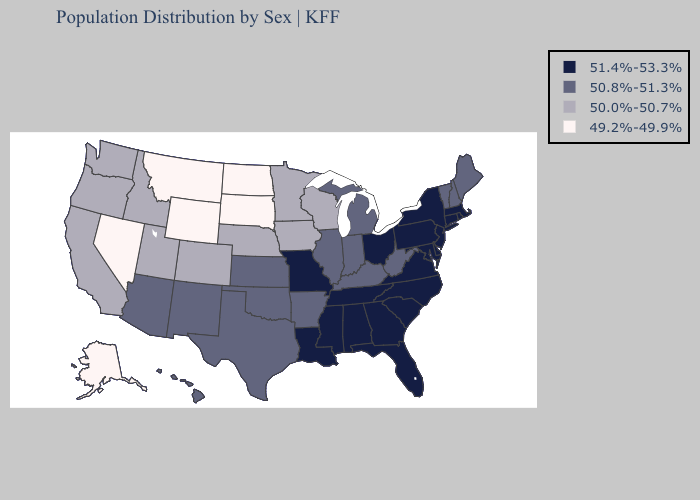Does Nevada have the same value as South Dakota?
Quick response, please. Yes. Among the states that border Tennessee , does Kentucky have the lowest value?
Short answer required. Yes. Name the states that have a value in the range 49.2%-49.9%?
Quick response, please. Alaska, Montana, Nevada, North Dakota, South Dakota, Wyoming. Name the states that have a value in the range 49.2%-49.9%?
Keep it brief. Alaska, Montana, Nevada, North Dakota, South Dakota, Wyoming. What is the value of Kentucky?
Be succinct. 50.8%-51.3%. Which states hav the highest value in the MidWest?
Concise answer only. Missouri, Ohio. Which states have the highest value in the USA?
Short answer required. Alabama, Connecticut, Delaware, Florida, Georgia, Louisiana, Maryland, Massachusetts, Mississippi, Missouri, New Jersey, New York, North Carolina, Ohio, Pennsylvania, Rhode Island, South Carolina, Tennessee, Virginia. Does Delaware have the highest value in the USA?
Answer briefly. Yes. Which states have the lowest value in the South?
Keep it brief. Arkansas, Kentucky, Oklahoma, Texas, West Virginia. What is the lowest value in the MidWest?
Answer briefly. 49.2%-49.9%. What is the highest value in states that border Ohio?
Be succinct. 51.4%-53.3%. What is the value of North Dakota?
Give a very brief answer. 49.2%-49.9%. Which states hav the highest value in the West?
Quick response, please. Arizona, Hawaii, New Mexico. Does Massachusetts have the highest value in the USA?
Give a very brief answer. Yes. 